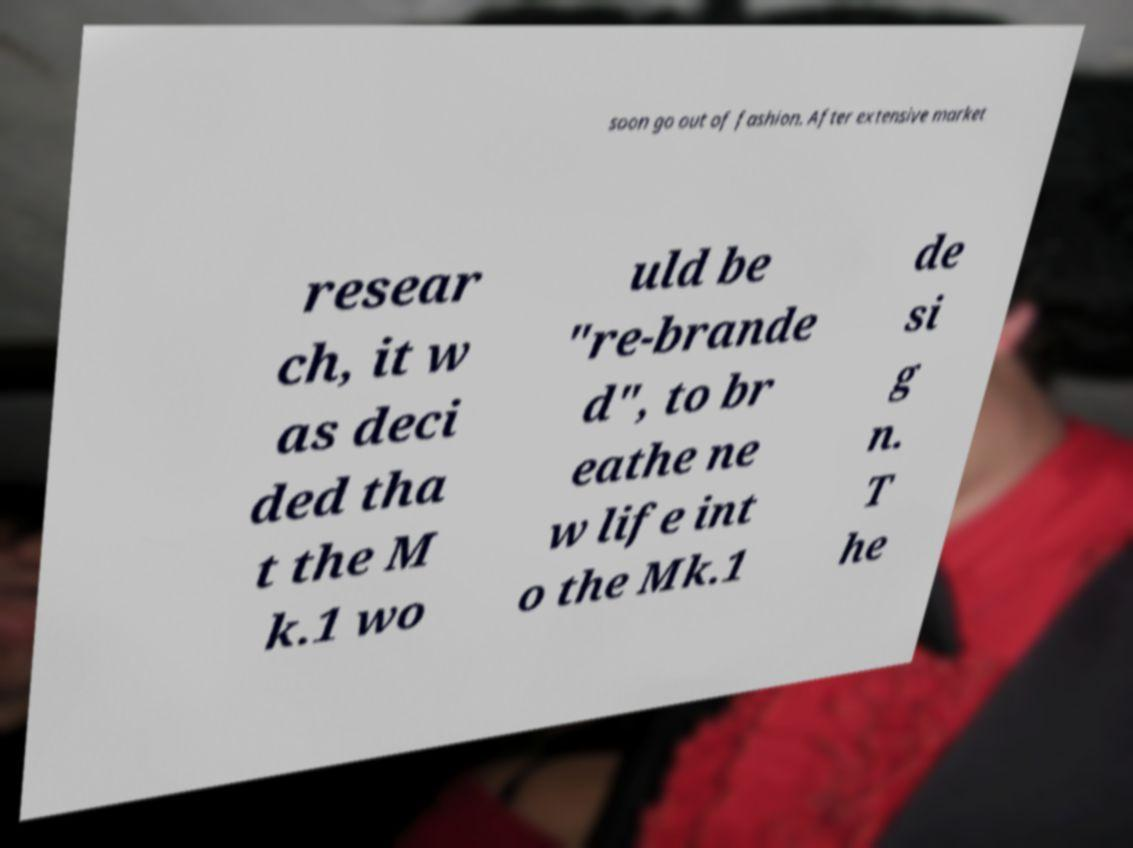Could you assist in decoding the text presented in this image and type it out clearly? soon go out of fashion. After extensive market resear ch, it w as deci ded tha t the M k.1 wo uld be "re-brande d", to br eathe ne w life int o the Mk.1 de si g n. T he 